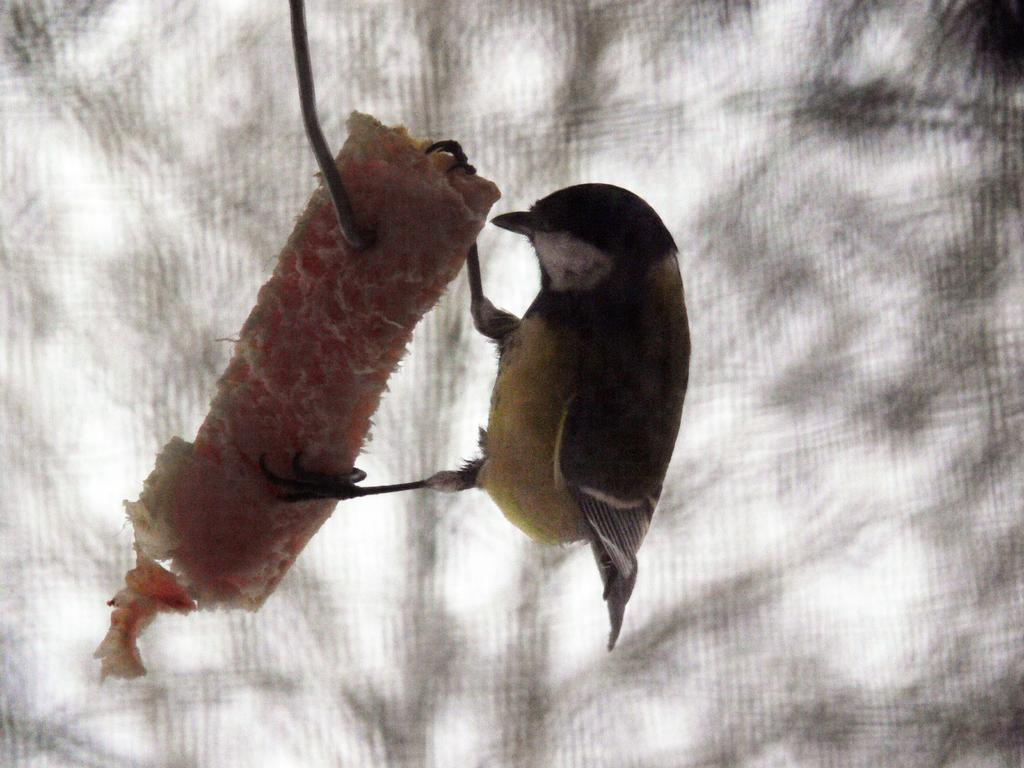What type of animal can be seen in the image? There is a bird in the image. What is the bird doing in the image? The bird is on food. How is the food attached in the image? The food is attached to an iron object. What is the color scheme of the image? The background of the image is in black and white. How many cows are visible in the image? There are no cows present in the image. Is the bird holding a gun in the image? There is no gun present in the image. 